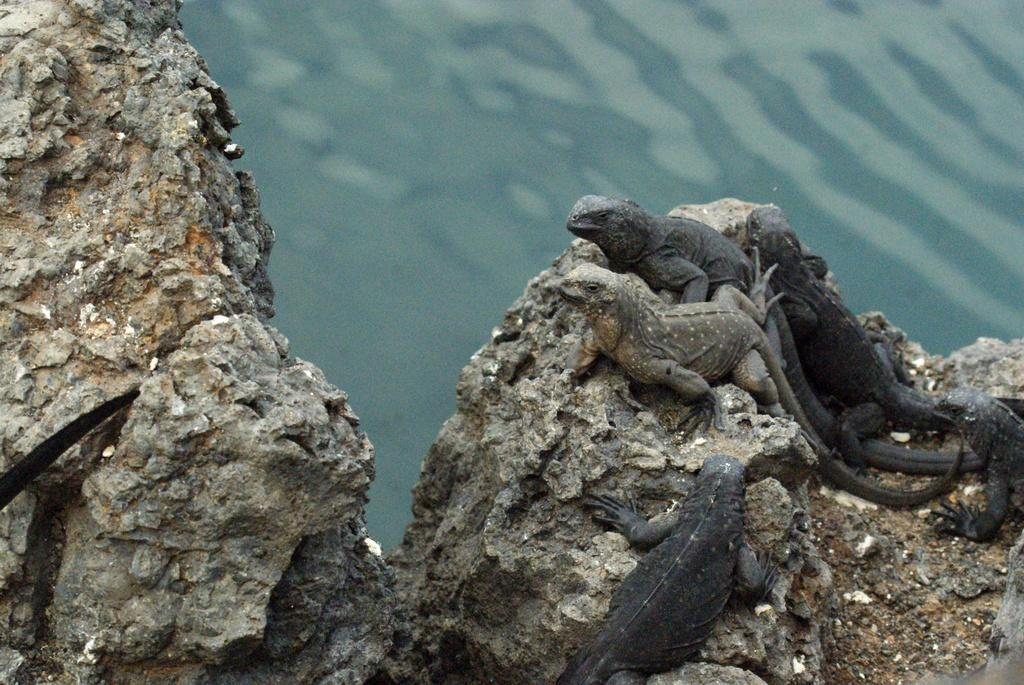What type of animals are in the image? There are reptiles in the image. What colors are the reptiles? The reptiles are brown and black in color. Where are the reptiles located in the image? The reptiles are on a rock. What can be seen in the background of the image? There is water visible in the background of the image. What type of fruit can be seen growing on the reptiles in the image? There is no fruit growing on the reptiles in the image; they are reptiles, not plants. 